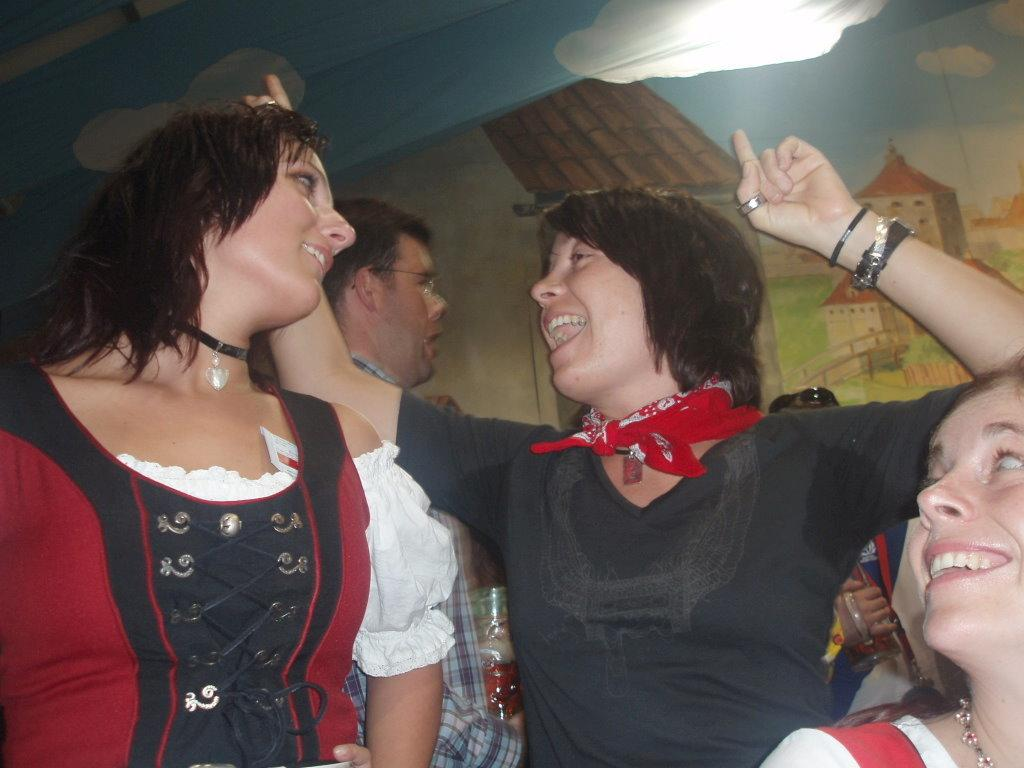Who or what is present in the image? There are persons in the image. Where are the persons located in the image? The persons are at the bottom of the image. What can be seen in the background of the image? There is a wall in the background of the image. What type of nerve can be seen in the image? There is no nerve present in the image. Is the image set during winter? The provided facts do not mention any seasonal context, so it cannot be determined if the image is set during winter. 